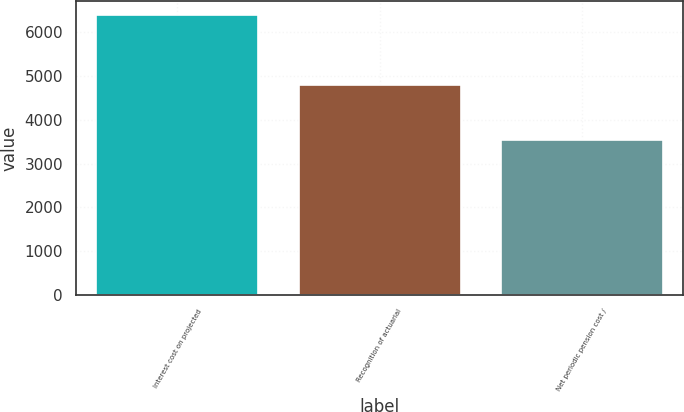Convert chart to OTSL. <chart><loc_0><loc_0><loc_500><loc_500><bar_chart><fcel>Interest cost on projected<fcel>Recognition of actuarial<fcel>Net periodic pension cost /<nl><fcel>6396<fcel>4800<fcel>3540<nl></chart> 